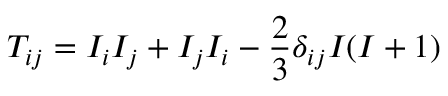Convert formula to latex. <formula><loc_0><loc_0><loc_500><loc_500>T _ { i j } = I _ { i } I _ { j } + I _ { j } I _ { i } - \frac { 2 } { 3 } \delta _ { i j } I ( I + 1 )</formula> 